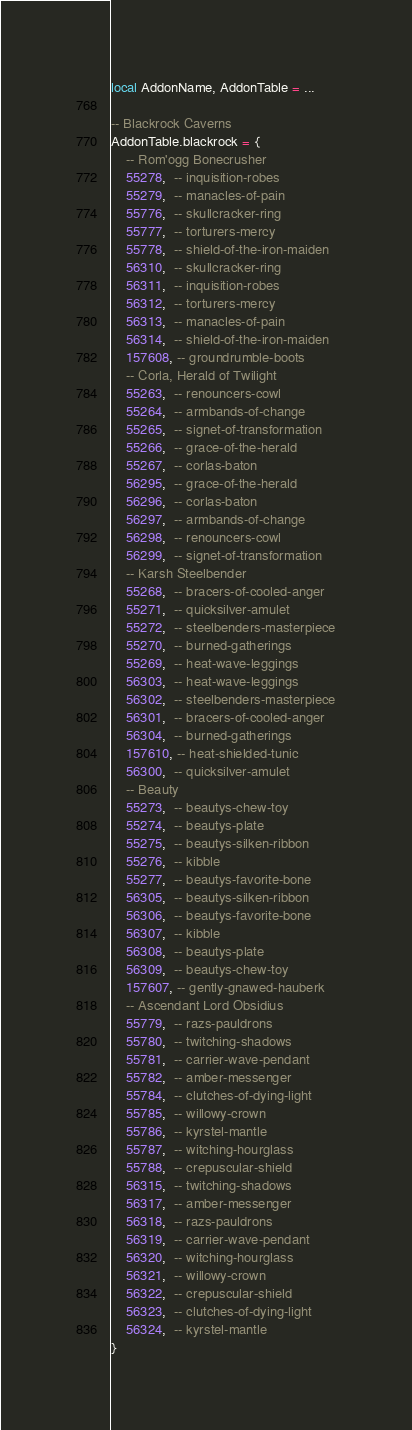<code> <loc_0><loc_0><loc_500><loc_500><_Lua_>local AddonName, AddonTable = ...

-- Blackrock Caverns
AddonTable.blackrock = {
    -- Rom'ogg Bonecrusher
    55278,  -- inquisition-robes
    55279,  -- manacles-of-pain
    55776,  -- skullcracker-ring
    55777,  -- torturers-mercy
    55778,  -- shield-of-the-iron-maiden
    56310,  -- skullcracker-ring
    56311,  -- inquisition-robes
    56312,  -- torturers-mercy
    56313,  -- manacles-of-pain
    56314,  -- shield-of-the-iron-maiden
    157608, -- groundrumble-boots
    -- Corla, Herald of Twilight
    55263,  -- renouncers-cowl
    55264,  -- armbands-of-change
    55265,  -- signet-of-transformation
    55266,  -- grace-of-the-herald
    55267,  -- corlas-baton
    56295,  -- grace-of-the-herald
    56296,  -- corlas-baton
    56297,  -- armbands-of-change
    56298,  -- renouncers-cowl
    56299,  -- signet-of-transformation
    -- Karsh Steelbender
    55268,  -- bracers-of-cooled-anger
    55271,  -- quicksilver-amulet
    55272,  -- steelbenders-masterpiece
    55270,  -- burned-gatherings
    55269,  -- heat-wave-leggings
    56303,  -- heat-wave-leggings
    56302,  -- steelbenders-masterpiece
    56301,  -- bracers-of-cooled-anger
    56304,  -- burned-gatherings
    157610, -- heat-shielded-tunic
    56300,  -- quicksilver-amulet
    -- Beauty
    55273,  -- beautys-chew-toy
    55274,  -- beautys-plate
    55275,  -- beautys-silken-ribbon
    55276,  -- kibble
    55277,  -- beautys-favorite-bone
    56305,  -- beautys-silken-ribbon
    56306,  -- beautys-favorite-bone
    56307,  -- kibble
    56308,  -- beautys-plate
    56309,  -- beautys-chew-toy
    157607, -- gently-gnawed-hauberk
    -- Ascendant Lord Obsidius
    55779,  -- razs-pauldrons
    55780,  -- twitching-shadows
    55781,  -- carrier-wave-pendant
    55782,  -- amber-messenger
    55784,  -- clutches-of-dying-light
    55785,  -- willowy-crown
    55786,  -- kyrstel-mantle
    55787,  -- witching-hourglass
    55788,  -- crepuscular-shield
    56315,  -- twitching-shadows
    56317,  -- amber-messenger
    56318,  -- razs-pauldrons
    56319,  -- carrier-wave-pendant
    56320,  -- witching-hourglass
    56321,  -- willowy-crown
    56322,  -- crepuscular-shield
    56323,  -- clutches-of-dying-light
    56324,  -- kyrstel-mantle
}
</code> 